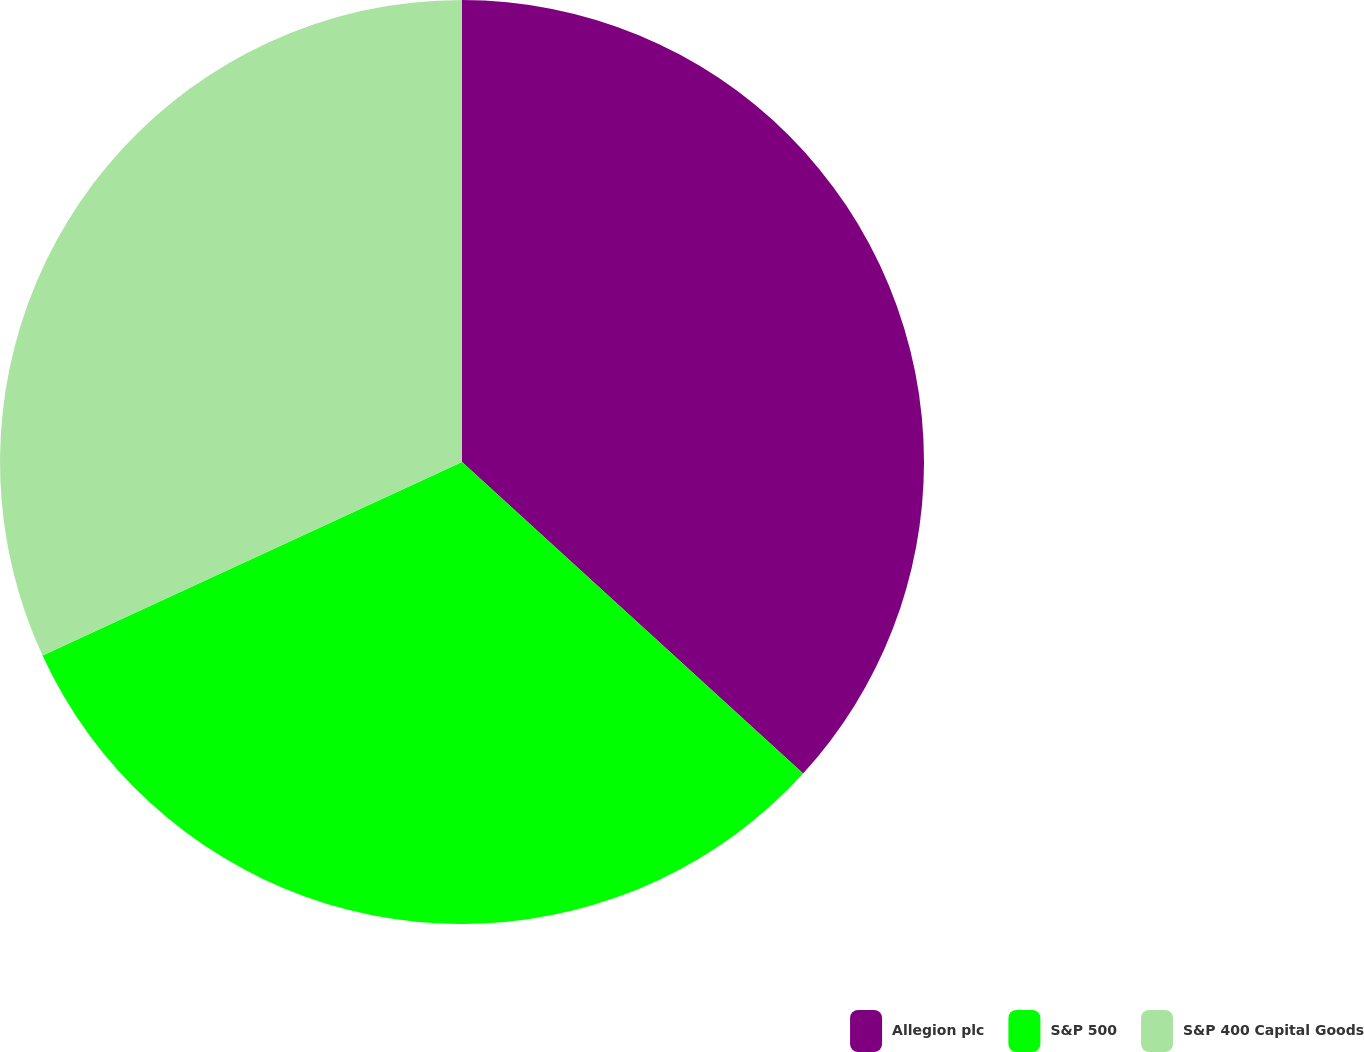<chart> <loc_0><loc_0><loc_500><loc_500><pie_chart><fcel>Allegion plc<fcel>S&P 500<fcel>S&P 400 Capital Goods<nl><fcel>36.78%<fcel>31.34%<fcel>31.88%<nl></chart> 